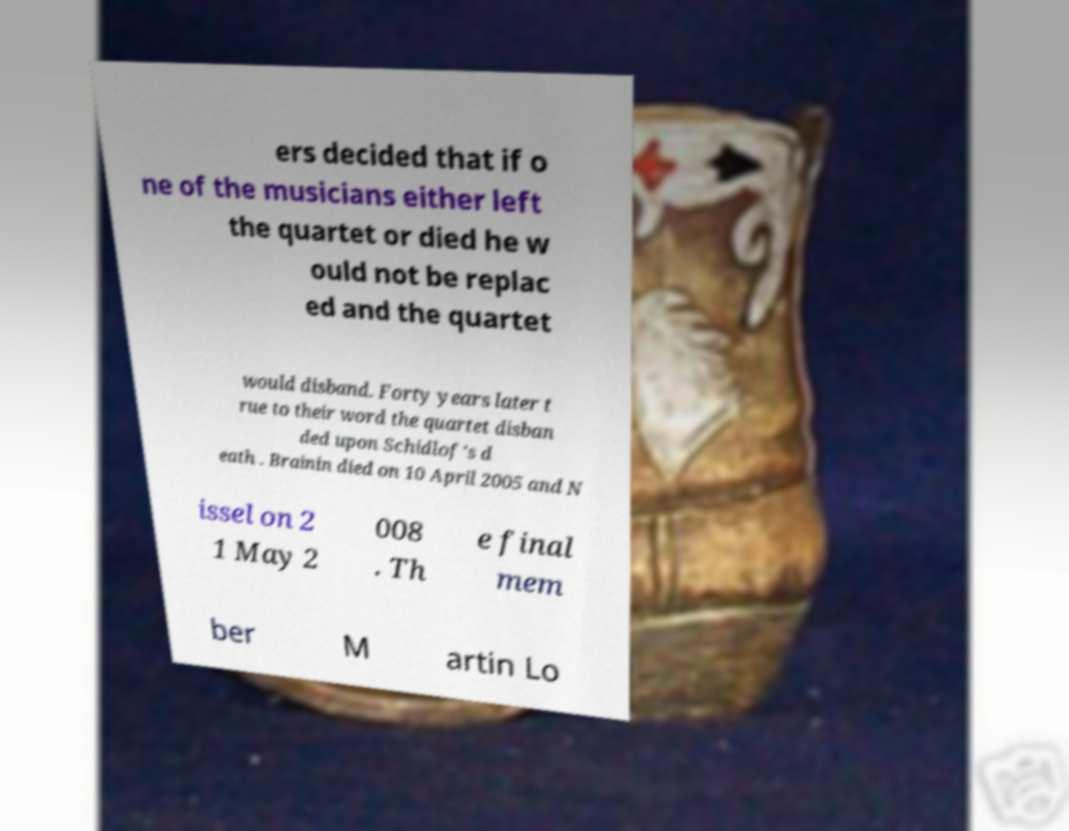Please identify and transcribe the text found in this image. ers decided that if o ne of the musicians either left the quartet or died he w ould not be replac ed and the quartet would disband. Forty years later t rue to their word the quartet disban ded upon Schidlof's d eath . Brainin died on 10 April 2005 and N issel on 2 1 May 2 008 . Th e final mem ber M artin Lo 